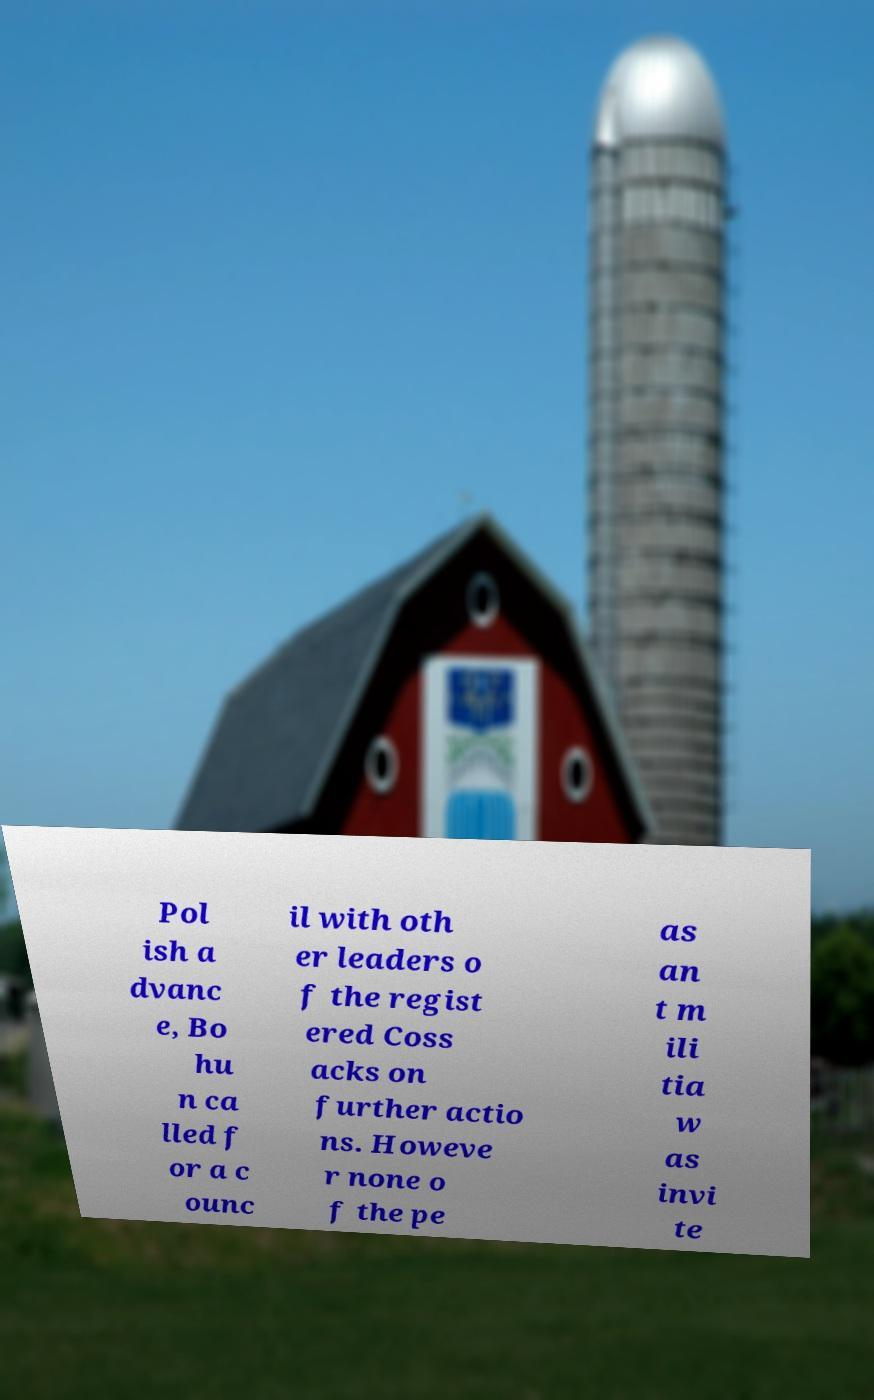Can you read and provide the text displayed in the image?This photo seems to have some interesting text. Can you extract and type it out for me? Pol ish a dvanc e, Bo hu n ca lled f or a c ounc il with oth er leaders o f the regist ered Coss acks on further actio ns. Howeve r none o f the pe as an t m ili tia w as invi te 